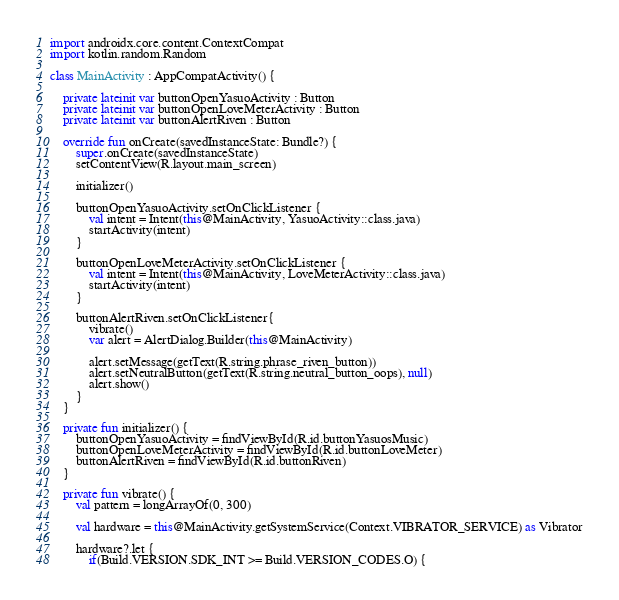<code> <loc_0><loc_0><loc_500><loc_500><_Kotlin_>import androidx.core.content.ContextCompat
import kotlin.random.Random

class MainActivity : AppCompatActivity() {

    private lateinit var buttonOpenYasuoActivity : Button
    private lateinit var buttonOpenLoveMeterActivity : Button
    private lateinit var buttonAlertRiven : Button

    override fun onCreate(savedInstanceState: Bundle?) {
        super.onCreate(savedInstanceState)
        setContentView(R.layout.main_screen)

        initializer()

        buttonOpenYasuoActivity.setOnClickListener {
            val intent = Intent(this@MainActivity, YasuoActivity::class.java)
            startActivity(intent)
        }

        buttonOpenLoveMeterActivity.setOnClickListener {
            val intent = Intent(this@MainActivity, LoveMeterActivity::class.java)
            startActivity(intent)
        }

        buttonAlertRiven.setOnClickListener{
            vibrate()
            var alert = AlertDialog.Builder(this@MainActivity)

            alert.setMessage(getText(R.string.phrase_riven_button))
            alert.setNeutralButton(getText(R.string.neutral_button_oops), null)
            alert.show()
        }
    }

    private fun initializer() {
        buttonOpenYasuoActivity = findViewById(R.id.buttonYasuosMusic)
        buttonOpenLoveMeterActivity = findViewById(R.id.buttonLoveMeter)
        buttonAlertRiven = findViewById(R.id.buttonRiven)
    }

    private fun vibrate() {
        val pattern = longArrayOf(0, 300)

        val hardware = this@MainActivity.getSystemService(Context.VIBRATOR_SERVICE) as Vibrator

        hardware?.let {
            if(Build.VERSION.SDK_INT >= Build.VERSION_CODES.O) {</code> 